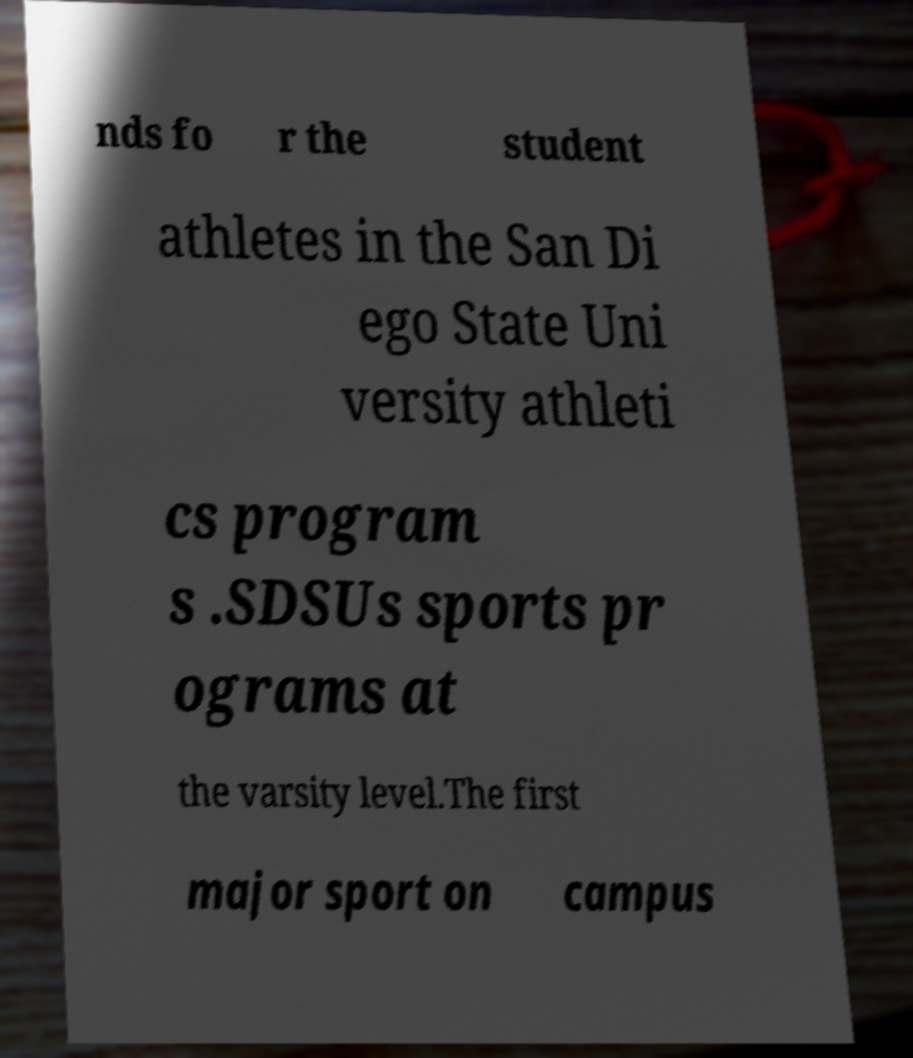Please read and relay the text visible in this image. What does it say? nds fo r the student athletes in the San Di ego State Uni versity athleti cs program s .SDSUs sports pr ograms at the varsity level.The first major sport on campus 